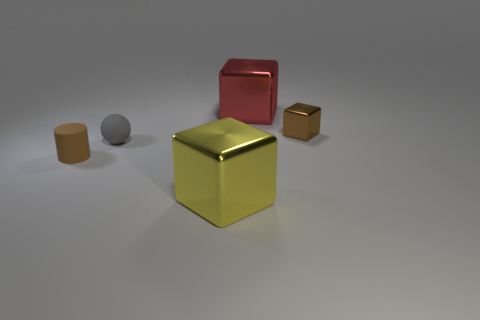Subtract all big metallic cubes. How many cubes are left? 1 Add 4 small blocks. How many objects exist? 9 Subtract 2 cubes. How many cubes are left? 1 Subtract all cylinders. How many objects are left? 4 Subtract all red blocks. Subtract all red balls. How many blocks are left? 2 Subtract all small rubber spheres. Subtract all large red metal things. How many objects are left? 3 Add 3 tiny brown shiny objects. How many tiny brown shiny objects are left? 4 Add 3 brown rubber things. How many brown rubber things exist? 4 Subtract 1 gray spheres. How many objects are left? 4 